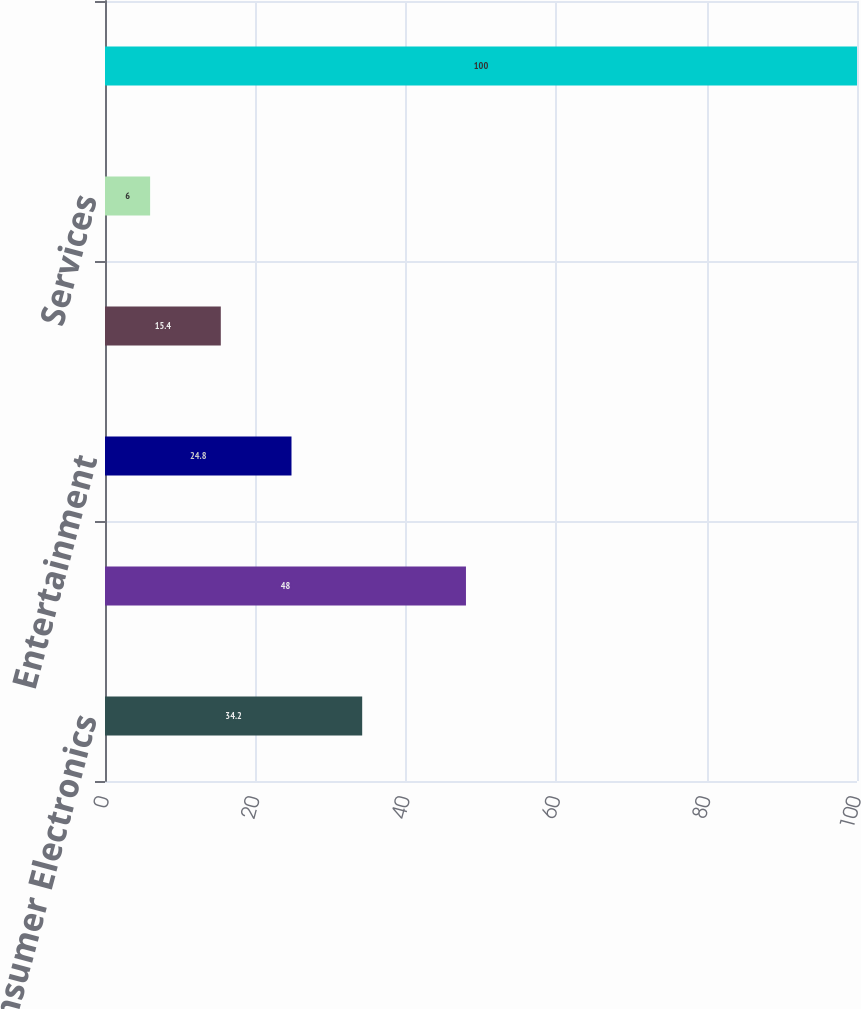Convert chart. <chart><loc_0><loc_0><loc_500><loc_500><bar_chart><fcel>Consumer Electronics<fcel>Computing and Mobile Phones<fcel>Entertainment<fcel>Appliances<fcel>Services<fcel>Total<nl><fcel>34.2<fcel>48<fcel>24.8<fcel>15.4<fcel>6<fcel>100<nl></chart> 